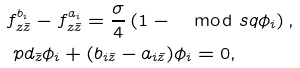Convert formula to latex. <formula><loc_0><loc_0><loc_500><loc_500>& f ^ { b _ { i } } _ { z \bar { z } } - f ^ { a _ { i } } _ { z \bar { z } } = \frac { \sigma } { 4 } \left ( 1 - \mod s q { \phi _ { i } } \right ) , \\ & \ p d _ { \bar { z } } \phi _ { i } + ( b _ { i \bar { z } } - a _ { i \bar { z } } ) \phi _ { i } = 0 ,</formula> 